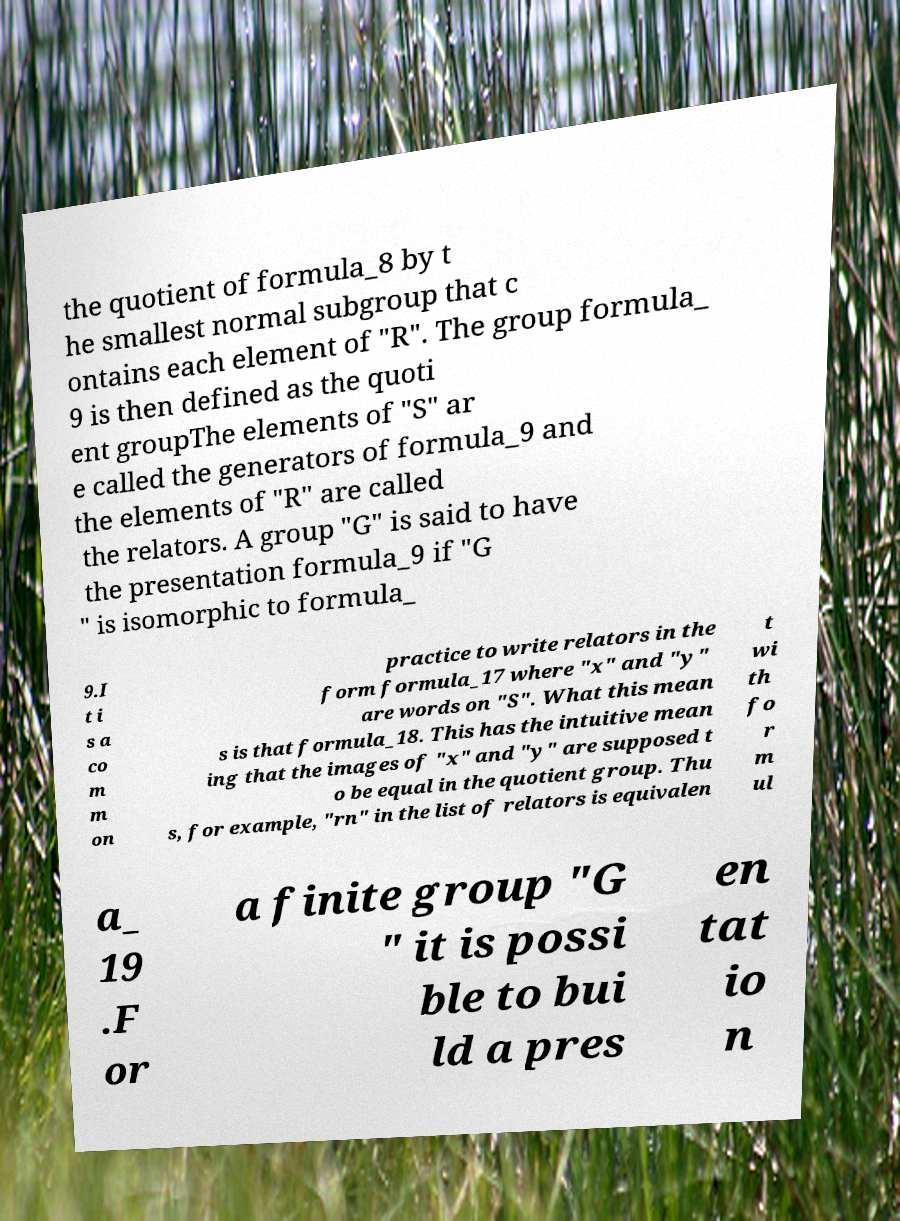Can you read and provide the text displayed in the image?This photo seems to have some interesting text. Can you extract and type it out for me? the quotient of formula_8 by t he smallest normal subgroup that c ontains each element of "R". The group formula_ 9 is then defined as the quoti ent groupThe elements of "S" ar e called the generators of formula_9 and the elements of "R" are called the relators. A group "G" is said to have the presentation formula_9 if "G " is isomorphic to formula_ 9.I t i s a co m m on practice to write relators in the form formula_17 where "x" and "y" are words on "S". What this mean s is that formula_18. This has the intuitive mean ing that the images of "x" and "y" are supposed t o be equal in the quotient group. Thu s, for example, "rn" in the list of relators is equivalen t wi th fo r m ul a_ 19 .F or a finite group "G " it is possi ble to bui ld a pres en tat io n 